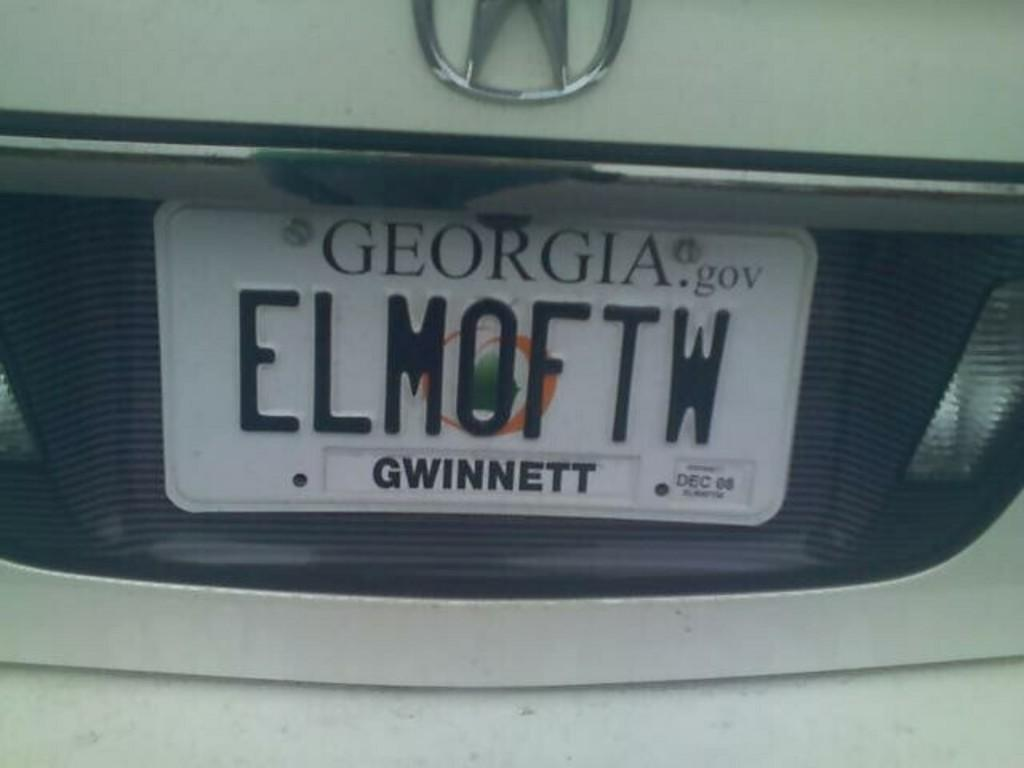Provide a one-sentence caption for the provided image. A Georgia licence plate for the Gwinnett county. 